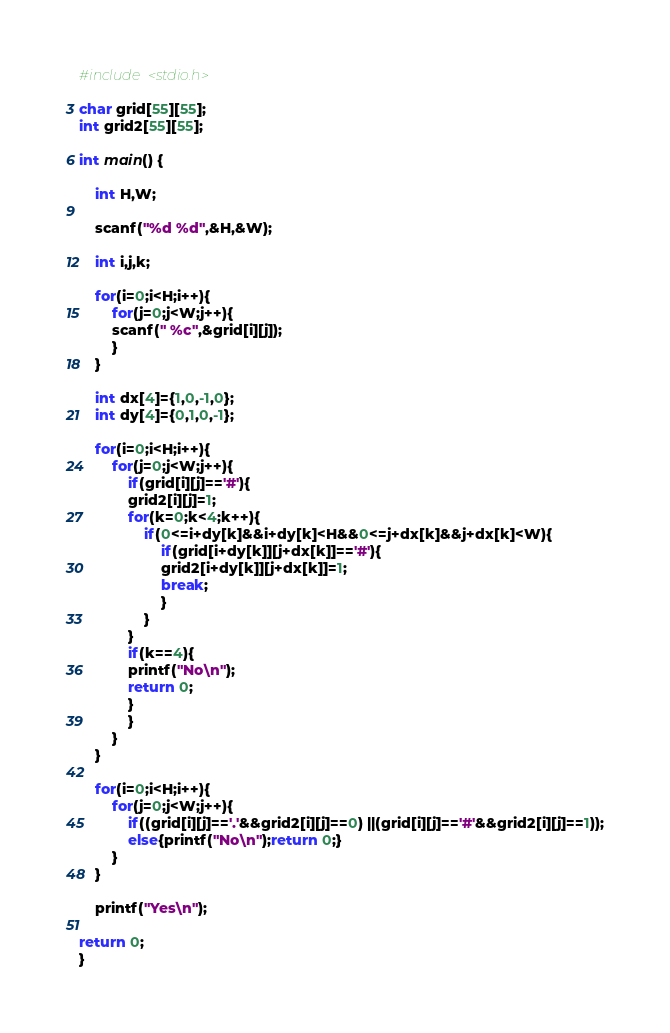Convert code to text. <code><loc_0><loc_0><loc_500><loc_500><_C_>#include <stdio.h>

char grid[55][55];
int grid2[55][55];

int main() {

	int H,W;

	scanf("%d %d",&H,&W);

	int i,j,k;

	for(i=0;i<H;i++){
		for(j=0;j<W;j++){
		scanf(" %c",&grid[i][j]);
		}
	}

	int dx[4]={1,0,-1,0};
	int dy[4]={0,1,0,-1};

	for(i=0;i<H;i++){
		for(j=0;j<W;j++){
			if(grid[i][j]=='#'){
			grid2[i][j]=1;
			for(k=0;k<4;k++){
				if(0<=i+dy[k]&&i+dy[k]<H&&0<=j+dx[k]&&j+dx[k]<W){
					if(grid[i+dy[k]][j+dx[k]]=='#'){
					grid2[i+dy[k]][j+dx[k]]=1;
					break;
					}
				}
			}
			if(k==4){
			printf("No\n");
			return 0;
			}
			}
		}
	}

	for(i=0;i<H;i++){
		for(j=0;j<W;j++){
			if((grid[i][j]=='.'&&grid2[i][j]==0) ||(grid[i][j]=='#'&&grid2[i][j]==1));
			else{printf("No\n");return 0;}
		}
	}

	printf("Yes\n");

return 0;
}</code> 